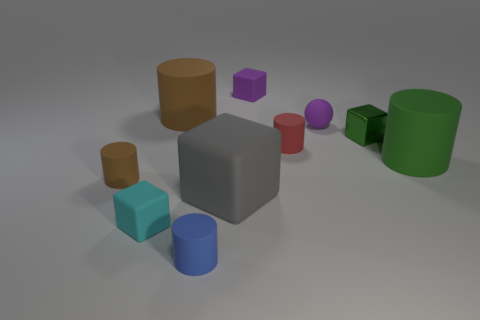Subtract all small cylinders. How many cylinders are left? 2 Subtract all blocks. How many objects are left? 6 Subtract all red cylinders. How many cylinders are left? 4 Subtract 0 gray balls. How many objects are left? 10 Subtract all gray cylinders. Subtract all blue balls. How many cylinders are left? 5 Subtract all yellow cylinders. How many cyan cubes are left? 1 Subtract all gray matte objects. Subtract all cylinders. How many objects are left? 4 Add 8 cyan blocks. How many cyan blocks are left? 9 Add 10 tiny gray blocks. How many tiny gray blocks exist? 10 